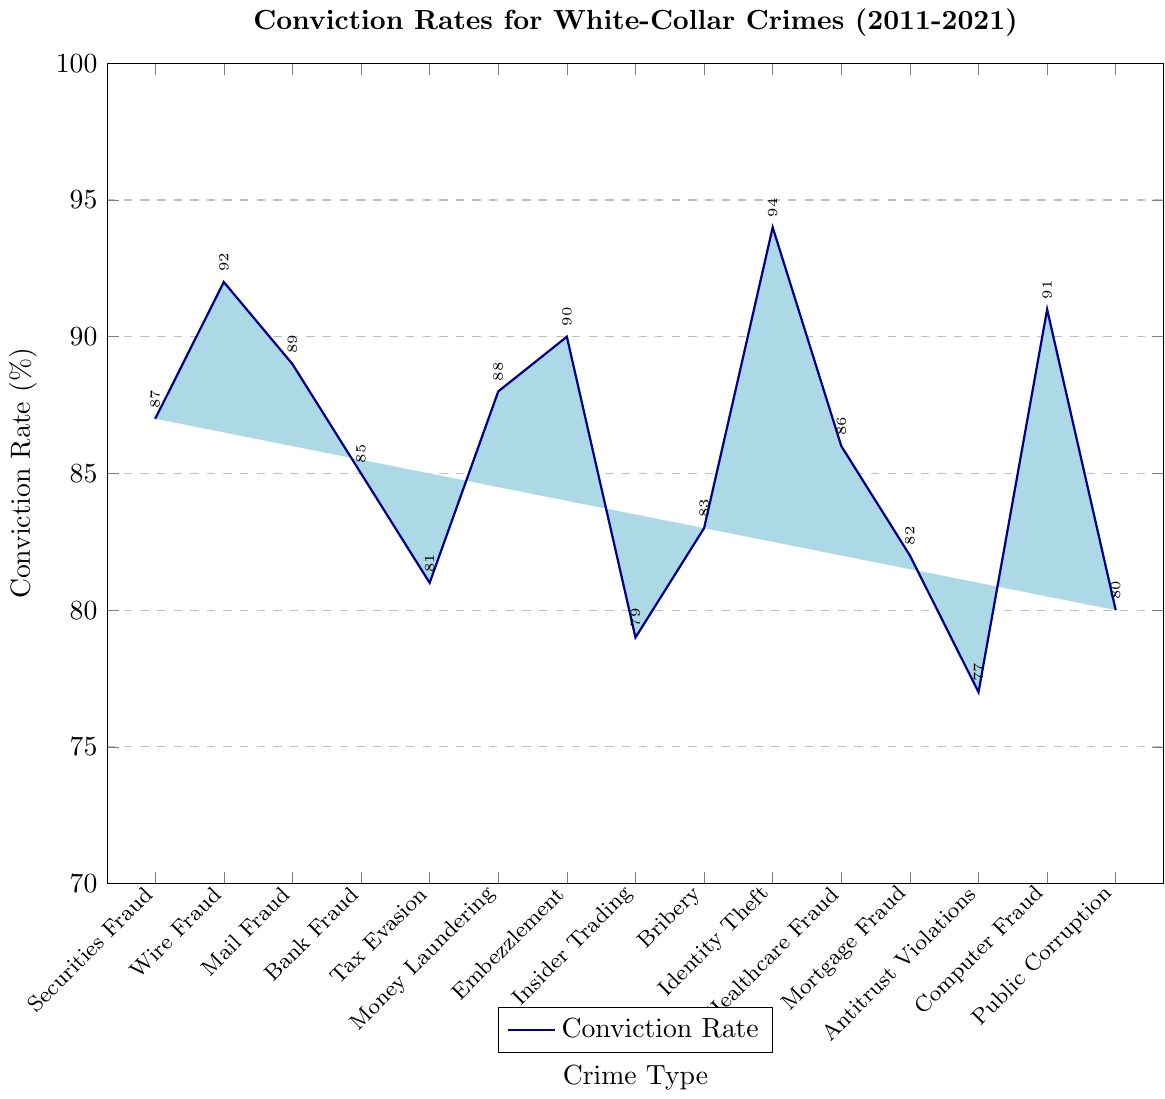What's the conviction rate for Identity Theft compared to Tax Evasion? Identity Theft has a conviction rate of 94%, and Tax Evasion has a conviction rate of 81%. So, Identity Theft's conviction rate is higher.
Answer: Identity Theft has a higher conviction rate (94% vs. 81%) Which crime has the lowest conviction rate? By examining the heights of the bars, Antitrust Violations has the lowest conviction rate at 77%.
Answer: Antitrust Violations What's the difference in conviction rate between Wire Fraud and Bank Fraud? The conviction rate for Wire Fraud is 92% and for Bank Fraud is 85%. The difference is 92 - 85 = 7%.
Answer: 7% What is the average conviction rate across all crime types? Sum all conviction rates and then divide by the number of crime types. (87 + 92 + 89 + 85 + 81 + 88 + 90 + 79 + 83 + 94 + 86 + 82 + 77 + 91 + 80) / 15 = 1304 / 15 = 86.93%.
Answer: 86.93% Is the conviction rate for Public Corruption higher or lower than for Embezzlement? Public Corruption has a conviction rate of 80%, and Embezzlement has a conviction rate of 90%. So, it's lower.
Answer: Lower Which crimes have a conviction rate that is greater than 90%? Looking at the bars, the crimes with conviction rates above 90% are Wire Fraud (92%), Identity Theft (94%), and Computer Fraud (91%).
Answer: Wire Fraud, Identity Theft, Computer Fraud What's the sum of the conviction rates for Mail Fraud, Bribery, and Healthcare Fraud? Add the conviction rates for those three crimes: Mail Fraud (89), Bribery (83), and Healthcare Fraud (86). So, 89 + 83 + 86 = 258.
Answer: 258 Which crime has a conviction rate closest to 85%? Bank Fraud and Healthcare Fraud have conviction rates close to 85%. Bank Fraud has exactly 85%, and Healthcare Fraud has 86%. Bank Fraud is exactly 85%.
Answer: Bank Fraud Arrange the top three crimes in descending order of their conviction rates. The three highest conviction rates are for Identity Theft (94%), Wire Fraud (92%), and Computer Fraud (91%). Arranged in descending order: Identity Theft, Wire Fraud, Computer Fraud.
Answer: Identity Theft, Wire Fraud, Computer Fraud How many crime types have a conviction rate that falls between 80% and 90%? Count the bars whose conviction rates fall between 80% and 90%. These are Securities Fraud, Mail Fraud, Bank Fraud, Tax Evasion, Money Laundering, Embezzlement, Bribery, Healthcare Fraud, Mortgage Fraud, and Public Corruption. So, there are 10 crimes.
Answer: 10 